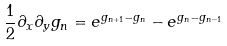<formula> <loc_0><loc_0><loc_500><loc_500>\frac { 1 } { 2 } \partial _ { x } \partial _ { y } g _ { n } = e ^ { g _ { n + 1 } - g _ { n } } - e ^ { g _ { n } - g _ { n - 1 } }</formula> 